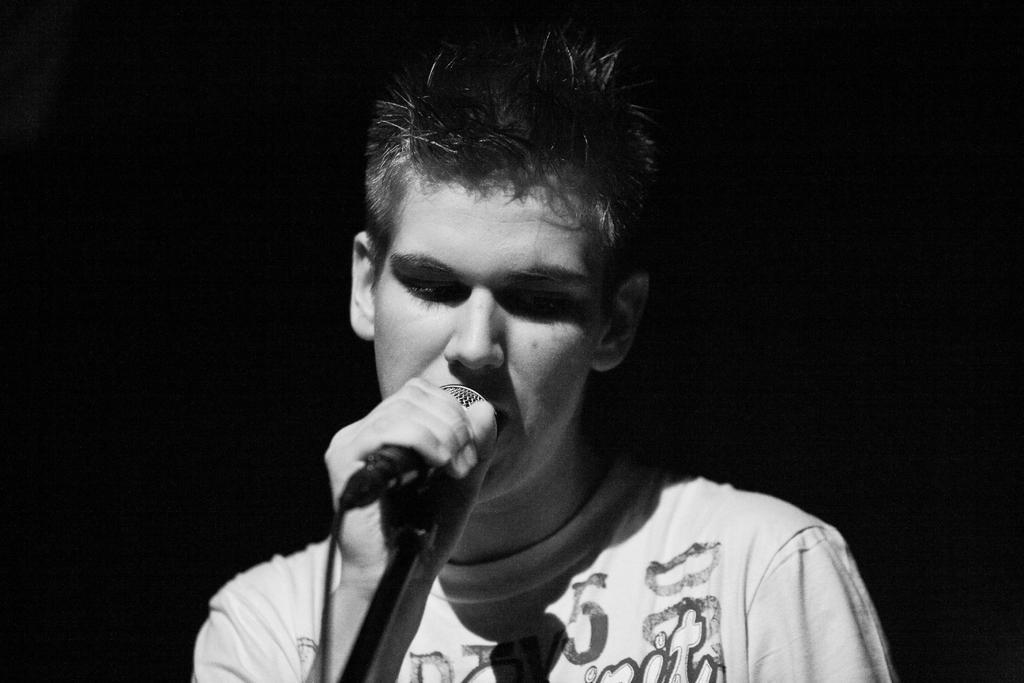Please provide a concise description of this image. In this Picture we can see the a boy wearing white t- shirt is singing in the microphone attached with the stand and hold in the left hand. 